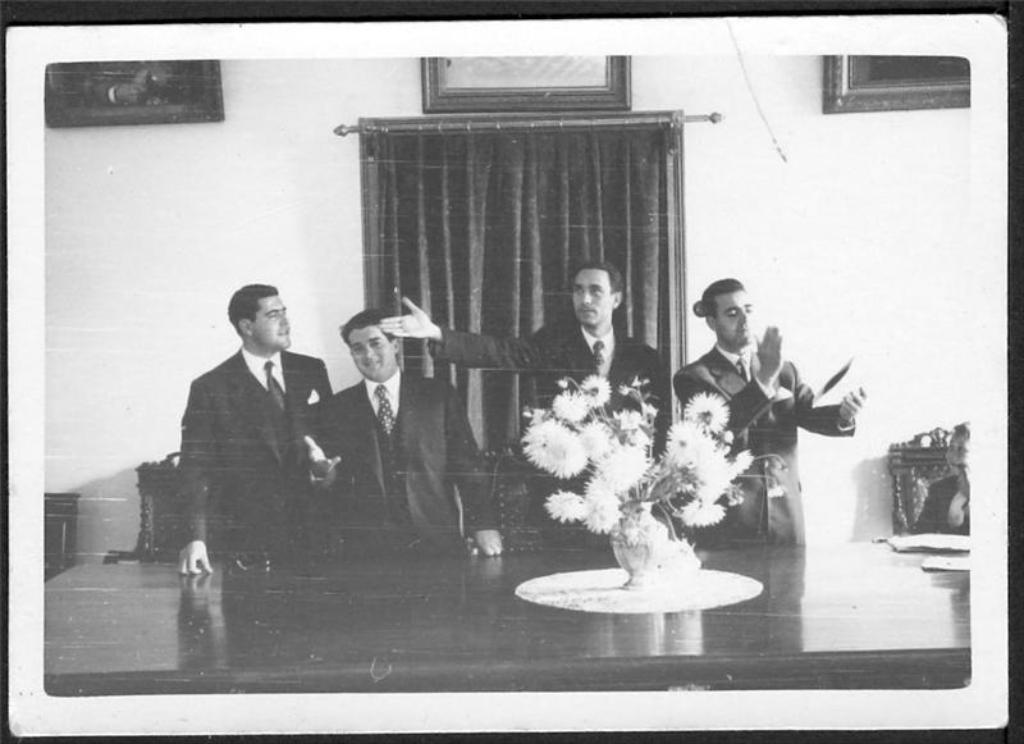What is the color scheme of the image? The image is black and white. How many men are present in the image? There are four men standing in the image. What are the men wearing? The men are wearing black coats. What else can be seen in the image besides the men? There is a curtain visible in the image. What scientific discovery is being celebrated by the men in the image? There is no indication of a scientific discovery or celebration in the image; it simply shows four men wearing black coats and standing near a curtain. 